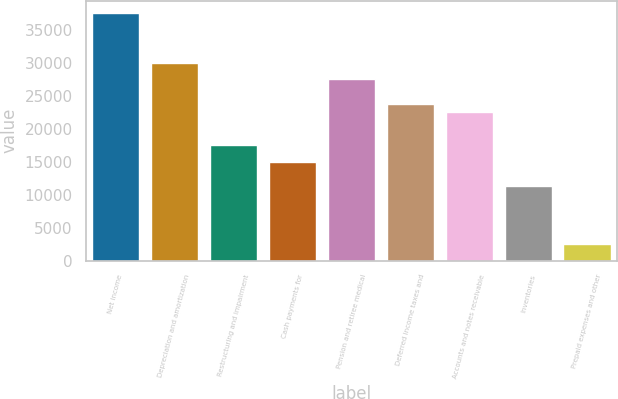Convert chart. <chart><loc_0><loc_0><loc_500><loc_500><bar_chart><fcel>Net income<fcel>Depreciation and amortization<fcel>Restructuring and impairment<fcel>Cash payments for<fcel>Pension and retiree medical<fcel>Deferred income taxes and<fcel>Accounts and notes receivable<fcel>Inventories<fcel>Prepaid expenses and other<nl><fcel>37498<fcel>29999.8<fcel>17502.8<fcel>15003.4<fcel>27500.4<fcel>23751.3<fcel>22501.6<fcel>11254.3<fcel>2506.4<nl></chart> 